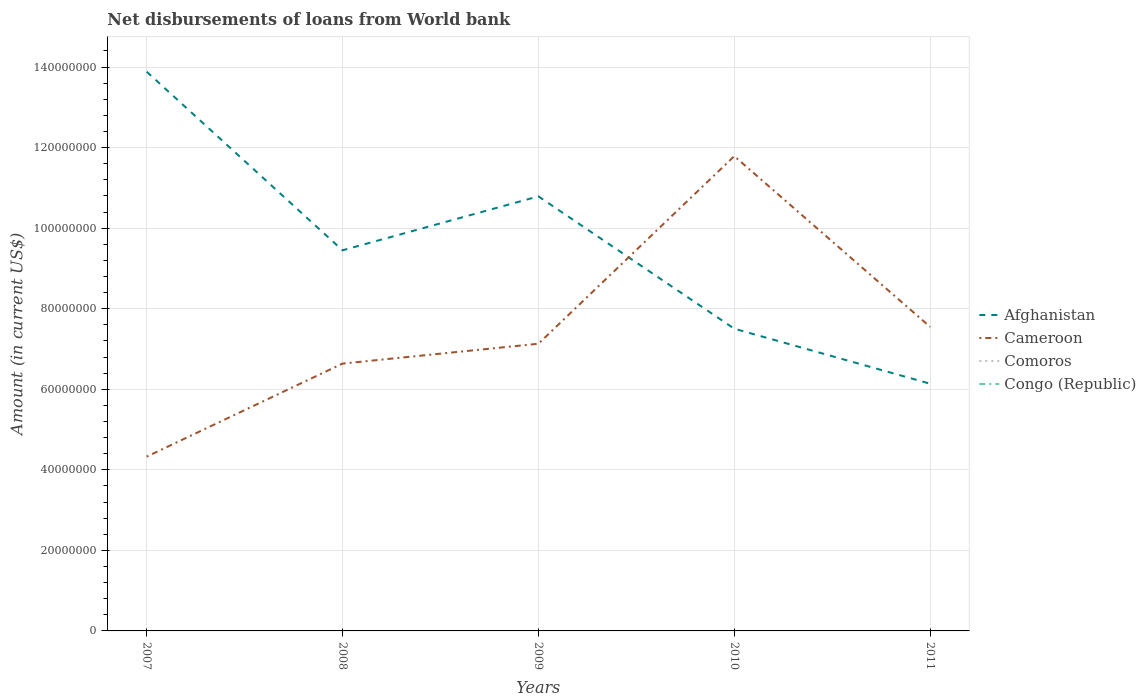Does the line corresponding to Comoros intersect with the line corresponding to Cameroon?
Ensure brevity in your answer.  No. Is the number of lines equal to the number of legend labels?
Ensure brevity in your answer.  No. Across all years, what is the maximum amount of loan disbursed from World Bank in Comoros?
Your answer should be very brief. 0. What is the total amount of loan disbursed from World Bank in Afghanistan in the graph?
Give a very brief answer. 7.75e+07. What is the difference between the highest and the second highest amount of loan disbursed from World Bank in Cameroon?
Ensure brevity in your answer.  7.46e+07. Is the amount of loan disbursed from World Bank in Congo (Republic) strictly greater than the amount of loan disbursed from World Bank in Cameroon over the years?
Offer a very short reply. Yes. How many lines are there?
Offer a very short reply. 2. Are the values on the major ticks of Y-axis written in scientific E-notation?
Your answer should be very brief. No. Where does the legend appear in the graph?
Provide a succinct answer. Center right. How many legend labels are there?
Offer a very short reply. 4. What is the title of the graph?
Provide a short and direct response. Net disbursements of loans from World bank. Does "Nepal" appear as one of the legend labels in the graph?
Make the answer very short. No. What is the label or title of the Y-axis?
Provide a succinct answer. Amount (in current US$). What is the Amount (in current US$) of Afghanistan in 2007?
Make the answer very short. 1.39e+08. What is the Amount (in current US$) of Cameroon in 2007?
Your answer should be compact. 4.33e+07. What is the Amount (in current US$) of Congo (Republic) in 2007?
Offer a terse response. 0. What is the Amount (in current US$) of Afghanistan in 2008?
Keep it short and to the point. 9.45e+07. What is the Amount (in current US$) of Cameroon in 2008?
Give a very brief answer. 6.64e+07. What is the Amount (in current US$) of Comoros in 2008?
Offer a terse response. 0. What is the Amount (in current US$) of Congo (Republic) in 2008?
Provide a short and direct response. 0. What is the Amount (in current US$) in Afghanistan in 2009?
Offer a very short reply. 1.08e+08. What is the Amount (in current US$) of Cameroon in 2009?
Offer a terse response. 7.13e+07. What is the Amount (in current US$) in Congo (Republic) in 2009?
Give a very brief answer. 0. What is the Amount (in current US$) of Afghanistan in 2010?
Give a very brief answer. 7.50e+07. What is the Amount (in current US$) in Cameroon in 2010?
Offer a very short reply. 1.18e+08. What is the Amount (in current US$) of Comoros in 2010?
Offer a terse response. 0. What is the Amount (in current US$) of Afghanistan in 2011?
Your response must be concise. 6.14e+07. What is the Amount (in current US$) of Cameroon in 2011?
Give a very brief answer. 7.55e+07. What is the Amount (in current US$) of Comoros in 2011?
Offer a terse response. 0. Across all years, what is the maximum Amount (in current US$) of Afghanistan?
Your answer should be compact. 1.39e+08. Across all years, what is the maximum Amount (in current US$) of Cameroon?
Ensure brevity in your answer.  1.18e+08. Across all years, what is the minimum Amount (in current US$) in Afghanistan?
Provide a succinct answer. 6.14e+07. Across all years, what is the minimum Amount (in current US$) of Cameroon?
Keep it short and to the point. 4.33e+07. What is the total Amount (in current US$) of Afghanistan in the graph?
Your answer should be compact. 4.78e+08. What is the total Amount (in current US$) of Cameroon in the graph?
Provide a short and direct response. 3.74e+08. What is the total Amount (in current US$) of Comoros in the graph?
Give a very brief answer. 0. What is the total Amount (in current US$) of Congo (Republic) in the graph?
Ensure brevity in your answer.  0. What is the difference between the Amount (in current US$) in Afghanistan in 2007 and that in 2008?
Provide a succinct answer. 4.43e+07. What is the difference between the Amount (in current US$) of Cameroon in 2007 and that in 2008?
Make the answer very short. -2.31e+07. What is the difference between the Amount (in current US$) of Afghanistan in 2007 and that in 2009?
Make the answer very short. 3.10e+07. What is the difference between the Amount (in current US$) in Cameroon in 2007 and that in 2009?
Your answer should be compact. -2.80e+07. What is the difference between the Amount (in current US$) in Afghanistan in 2007 and that in 2010?
Keep it short and to the point. 6.38e+07. What is the difference between the Amount (in current US$) in Cameroon in 2007 and that in 2010?
Provide a succinct answer. -7.46e+07. What is the difference between the Amount (in current US$) of Afghanistan in 2007 and that in 2011?
Give a very brief answer. 7.75e+07. What is the difference between the Amount (in current US$) in Cameroon in 2007 and that in 2011?
Offer a very short reply. -3.22e+07. What is the difference between the Amount (in current US$) of Afghanistan in 2008 and that in 2009?
Provide a short and direct response. -1.34e+07. What is the difference between the Amount (in current US$) in Cameroon in 2008 and that in 2009?
Your answer should be compact. -4.93e+06. What is the difference between the Amount (in current US$) of Afghanistan in 2008 and that in 2010?
Ensure brevity in your answer.  1.95e+07. What is the difference between the Amount (in current US$) of Cameroon in 2008 and that in 2010?
Your answer should be very brief. -5.15e+07. What is the difference between the Amount (in current US$) in Afghanistan in 2008 and that in 2011?
Ensure brevity in your answer.  3.31e+07. What is the difference between the Amount (in current US$) in Cameroon in 2008 and that in 2011?
Keep it short and to the point. -9.12e+06. What is the difference between the Amount (in current US$) in Afghanistan in 2009 and that in 2010?
Make the answer very short. 3.29e+07. What is the difference between the Amount (in current US$) of Cameroon in 2009 and that in 2010?
Offer a terse response. -4.66e+07. What is the difference between the Amount (in current US$) in Afghanistan in 2009 and that in 2011?
Offer a very short reply. 4.65e+07. What is the difference between the Amount (in current US$) in Cameroon in 2009 and that in 2011?
Provide a short and direct response. -4.19e+06. What is the difference between the Amount (in current US$) of Afghanistan in 2010 and that in 2011?
Ensure brevity in your answer.  1.37e+07. What is the difference between the Amount (in current US$) in Cameroon in 2010 and that in 2011?
Make the answer very short. 4.24e+07. What is the difference between the Amount (in current US$) of Afghanistan in 2007 and the Amount (in current US$) of Cameroon in 2008?
Ensure brevity in your answer.  7.25e+07. What is the difference between the Amount (in current US$) of Afghanistan in 2007 and the Amount (in current US$) of Cameroon in 2009?
Offer a terse response. 6.75e+07. What is the difference between the Amount (in current US$) of Afghanistan in 2007 and the Amount (in current US$) of Cameroon in 2010?
Ensure brevity in your answer.  2.10e+07. What is the difference between the Amount (in current US$) of Afghanistan in 2007 and the Amount (in current US$) of Cameroon in 2011?
Your response must be concise. 6.34e+07. What is the difference between the Amount (in current US$) of Afghanistan in 2008 and the Amount (in current US$) of Cameroon in 2009?
Make the answer very short. 2.32e+07. What is the difference between the Amount (in current US$) of Afghanistan in 2008 and the Amount (in current US$) of Cameroon in 2010?
Your answer should be very brief. -2.34e+07. What is the difference between the Amount (in current US$) in Afghanistan in 2008 and the Amount (in current US$) in Cameroon in 2011?
Your answer should be very brief. 1.90e+07. What is the difference between the Amount (in current US$) in Afghanistan in 2009 and the Amount (in current US$) in Cameroon in 2010?
Keep it short and to the point. -9.99e+06. What is the difference between the Amount (in current US$) of Afghanistan in 2009 and the Amount (in current US$) of Cameroon in 2011?
Provide a succinct answer. 3.24e+07. What is the difference between the Amount (in current US$) in Afghanistan in 2010 and the Amount (in current US$) in Cameroon in 2011?
Your answer should be very brief. -4.58e+05. What is the average Amount (in current US$) of Afghanistan per year?
Keep it short and to the point. 9.55e+07. What is the average Amount (in current US$) in Cameroon per year?
Provide a succinct answer. 7.49e+07. In the year 2007, what is the difference between the Amount (in current US$) in Afghanistan and Amount (in current US$) in Cameroon?
Provide a succinct answer. 9.56e+07. In the year 2008, what is the difference between the Amount (in current US$) in Afghanistan and Amount (in current US$) in Cameroon?
Your answer should be very brief. 2.81e+07. In the year 2009, what is the difference between the Amount (in current US$) in Afghanistan and Amount (in current US$) in Cameroon?
Offer a very short reply. 3.66e+07. In the year 2010, what is the difference between the Amount (in current US$) of Afghanistan and Amount (in current US$) of Cameroon?
Provide a succinct answer. -4.28e+07. In the year 2011, what is the difference between the Amount (in current US$) in Afghanistan and Amount (in current US$) in Cameroon?
Offer a terse response. -1.41e+07. What is the ratio of the Amount (in current US$) of Afghanistan in 2007 to that in 2008?
Keep it short and to the point. 1.47. What is the ratio of the Amount (in current US$) in Cameroon in 2007 to that in 2008?
Offer a terse response. 0.65. What is the ratio of the Amount (in current US$) of Afghanistan in 2007 to that in 2009?
Your response must be concise. 1.29. What is the ratio of the Amount (in current US$) in Cameroon in 2007 to that in 2009?
Offer a very short reply. 0.61. What is the ratio of the Amount (in current US$) in Afghanistan in 2007 to that in 2010?
Offer a terse response. 1.85. What is the ratio of the Amount (in current US$) in Cameroon in 2007 to that in 2010?
Provide a short and direct response. 0.37. What is the ratio of the Amount (in current US$) in Afghanistan in 2007 to that in 2011?
Your response must be concise. 2.26. What is the ratio of the Amount (in current US$) in Cameroon in 2007 to that in 2011?
Offer a terse response. 0.57. What is the ratio of the Amount (in current US$) of Afghanistan in 2008 to that in 2009?
Make the answer very short. 0.88. What is the ratio of the Amount (in current US$) of Cameroon in 2008 to that in 2009?
Your response must be concise. 0.93. What is the ratio of the Amount (in current US$) in Afghanistan in 2008 to that in 2010?
Keep it short and to the point. 1.26. What is the ratio of the Amount (in current US$) of Cameroon in 2008 to that in 2010?
Offer a terse response. 0.56. What is the ratio of the Amount (in current US$) of Afghanistan in 2008 to that in 2011?
Ensure brevity in your answer.  1.54. What is the ratio of the Amount (in current US$) in Cameroon in 2008 to that in 2011?
Ensure brevity in your answer.  0.88. What is the ratio of the Amount (in current US$) of Afghanistan in 2009 to that in 2010?
Provide a short and direct response. 1.44. What is the ratio of the Amount (in current US$) in Cameroon in 2009 to that in 2010?
Offer a very short reply. 0.6. What is the ratio of the Amount (in current US$) in Afghanistan in 2009 to that in 2011?
Your answer should be compact. 1.76. What is the ratio of the Amount (in current US$) in Cameroon in 2009 to that in 2011?
Make the answer very short. 0.94. What is the ratio of the Amount (in current US$) of Afghanistan in 2010 to that in 2011?
Give a very brief answer. 1.22. What is the ratio of the Amount (in current US$) of Cameroon in 2010 to that in 2011?
Ensure brevity in your answer.  1.56. What is the difference between the highest and the second highest Amount (in current US$) of Afghanistan?
Make the answer very short. 3.10e+07. What is the difference between the highest and the second highest Amount (in current US$) in Cameroon?
Provide a succinct answer. 4.24e+07. What is the difference between the highest and the lowest Amount (in current US$) in Afghanistan?
Provide a succinct answer. 7.75e+07. What is the difference between the highest and the lowest Amount (in current US$) in Cameroon?
Provide a succinct answer. 7.46e+07. 